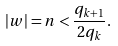<formula> <loc_0><loc_0><loc_500><loc_500>| w | = n < \frac { q _ { k + 1 } } { 2 q _ { k } } .</formula> 